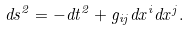Convert formula to latex. <formula><loc_0><loc_0><loc_500><loc_500>d s ^ { 2 } = - d t ^ { 2 } + g _ { i j } d x ^ { i } d x ^ { j } .</formula> 